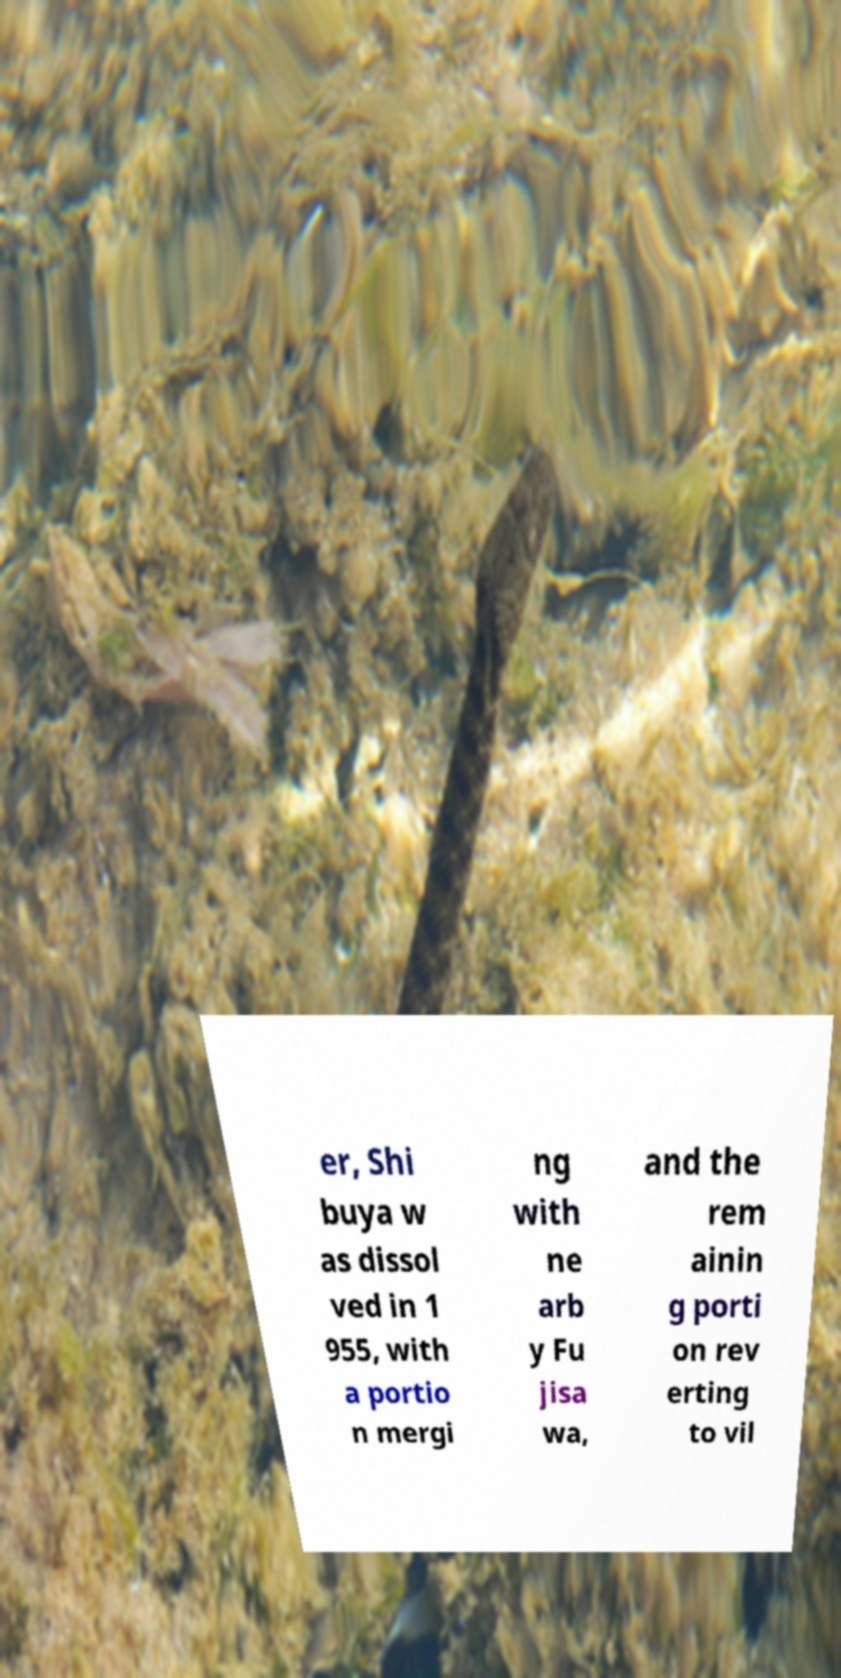There's text embedded in this image that I need extracted. Can you transcribe it verbatim? er, Shi buya w as dissol ved in 1 955, with a portio n mergi ng with ne arb y Fu jisa wa, and the rem ainin g porti on rev erting to vil 